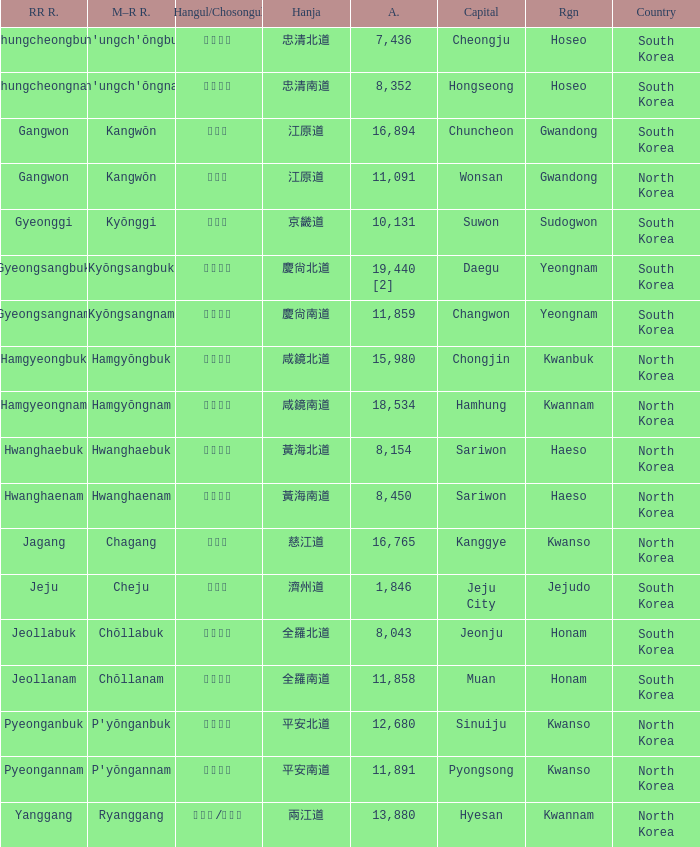What is the M-R Romaja for the province having a capital of Cheongju? Ch'ungch'ŏngbuk. 